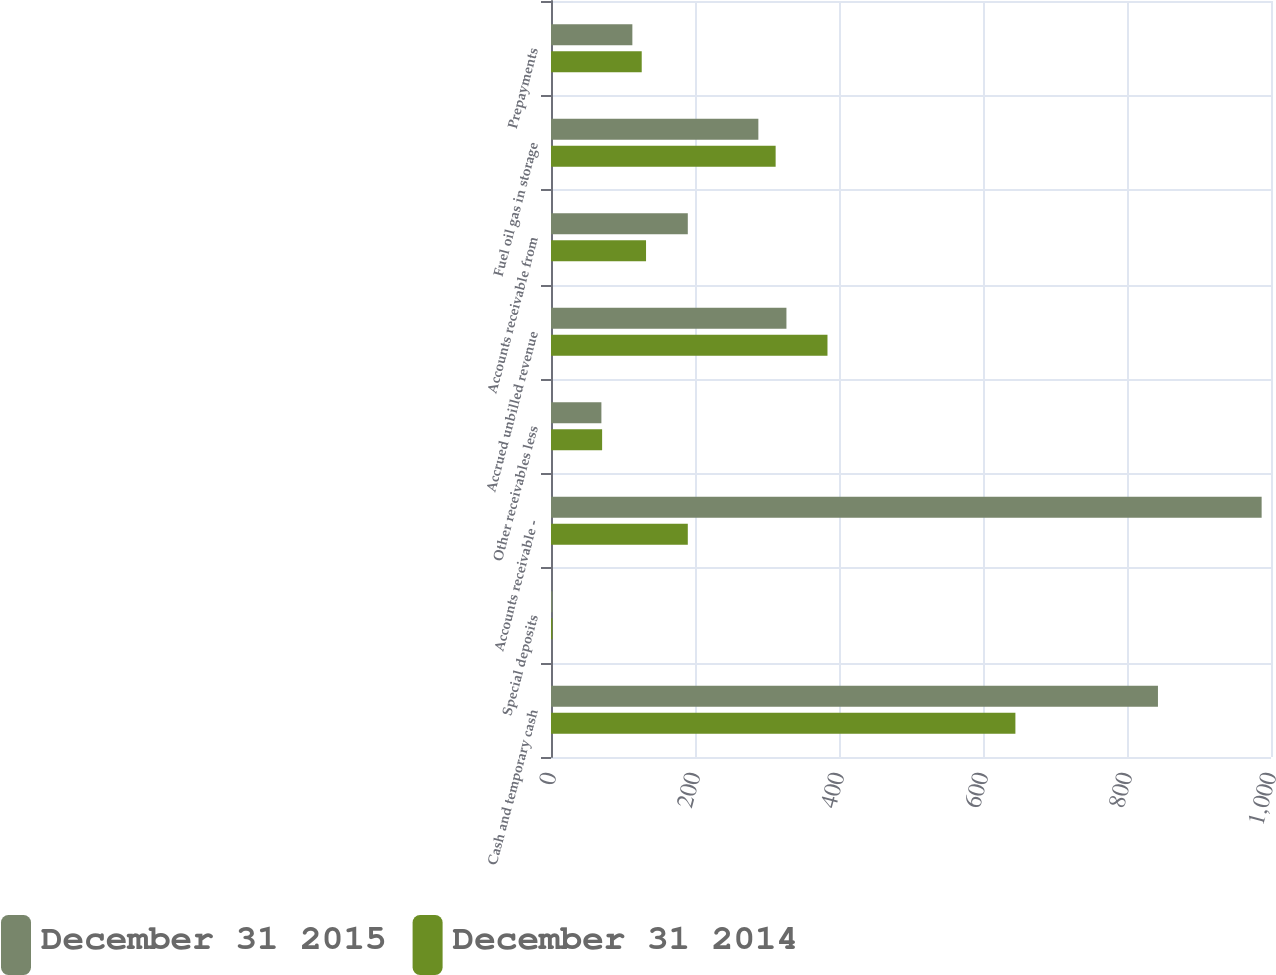<chart> <loc_0><loc_0><loc_500><loc_500><stacked_bar_chart><ecel><fcel>Cash and temporary cash<fcel>Special deposits<fcel>Accounts receivable -<fcel>Other receivables less<fcel>Accrued unbilled revenue<fcel>Accounts receivable from<fcel>Fuel oil gas in storage<fcel>Prepayments<nl><fcel>December 31 2015<fcel>843<fcel>2<fcel>987<fcel>70<fcel>327<fcel>190<fcel>288<fcel>113<nl><fcel>December 31 2014<fcel>645<fcel>2<fcel>190<fcel>71<fcel>384<fcel>132<fcel>312<fcel>126<nl></chart> 